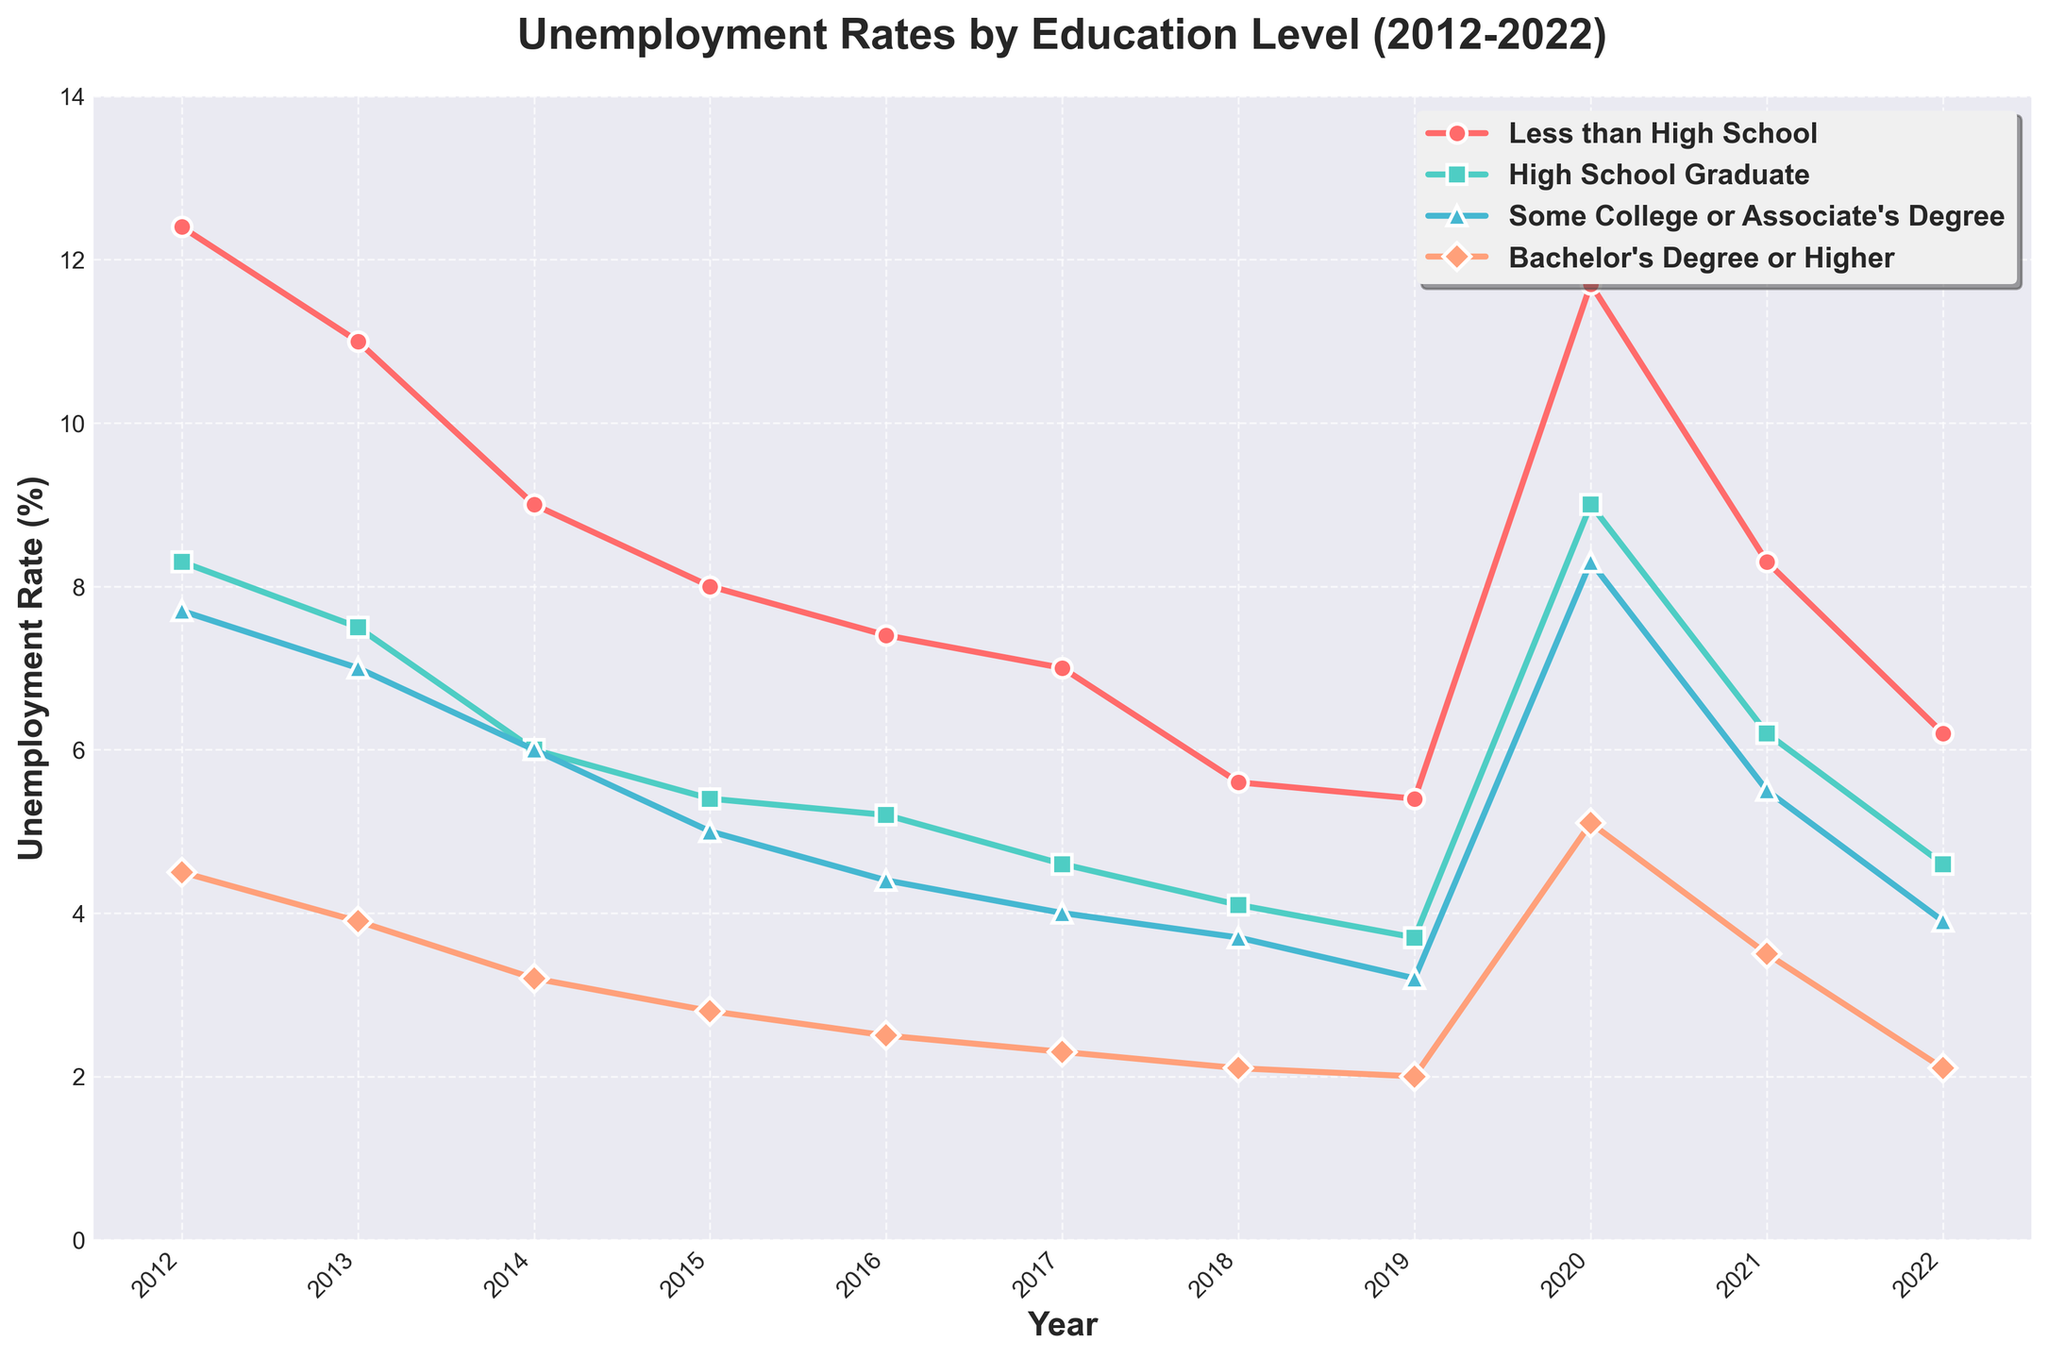Which education level had the highest unemployment rate in 2020? In 2020, the line corresponding to the "Less than High School" education level is the highest on the y-axis among all series, indicating the highest unemployment rate.
Answer: Less than High School Which education level showed the most significant decrease in unemployment rate from 2012 to 2022? The "Less than High School" education level line shows the largest drop from 12.4% in 2012 to 6.2% in 2022, indicating the most significant decrease.
Answer: Less than High School In which year did the "High School Graduate" category experience a noticeable peak in unemployment rate? The "High School Graduate" line shows a noticeable peak in 2020 with a spike to 9.0%, higher than any other year in the dataset for that category.
Answer: 2020 What was the difference in unemployment rate between "Some College or Associate's Degree" and "Bachelor's Degree or Higher" in 2019? In 2019, the unemployment rate for "Some College or Associate's Degree" was 3.2% and for "Bachelor's Degree or Higher" it was 2.0%. The difference is calculated as 3.2% - 2.0%.
Answer: 1.2% In which year did all education levels experience the lowest unemployment rates? By examining the lowest points on each line on the y-axis, it can be observed that the year 2019 shows the lowest unemployment rates for all education levels before they all rise again in 2020.
Answer: 2019 Which education level had a consistent decrease in unemployment rate every year from 2012 to 2019? The line for "Bachelor's Degree or Higher" shows a consistent year-on-year decrease in unemployment rates from 2012 to 2019.
Answer: Bachelor's Degree or Higher For "Less than High School", what is the average unemployment rate over the last decade? Summing up the unemployment rates for "Less than High School" from 2012 to 2022 (12.4, 11.0, 9.0, 8.0, 7.4, 7.0, 5.6, 5.4, 11.7, 8.3, 6.2) gives a total of 91.0. Dividing this sum by 11 provides the average.
Answer: 8.27 How did the unemployment rate for "High School Graduate" in 2021 compare to that in 2012? In 2012, the unemployment rate for "High School Graduate" was 8.3%, and in 2021, it was 6.2%. Comparing these values, 2021's rate is lower than 2012's.
Answer: Lower Which education group had the smallest fluctuation in its unemployment rate between 2012 and 2022? The "Bachelor's Degree or Higher" category shows the smallest fluctuation as the line remains the most stable and has the smallest range of values over the years.
Answer: Bachelor's Degree or Higher 